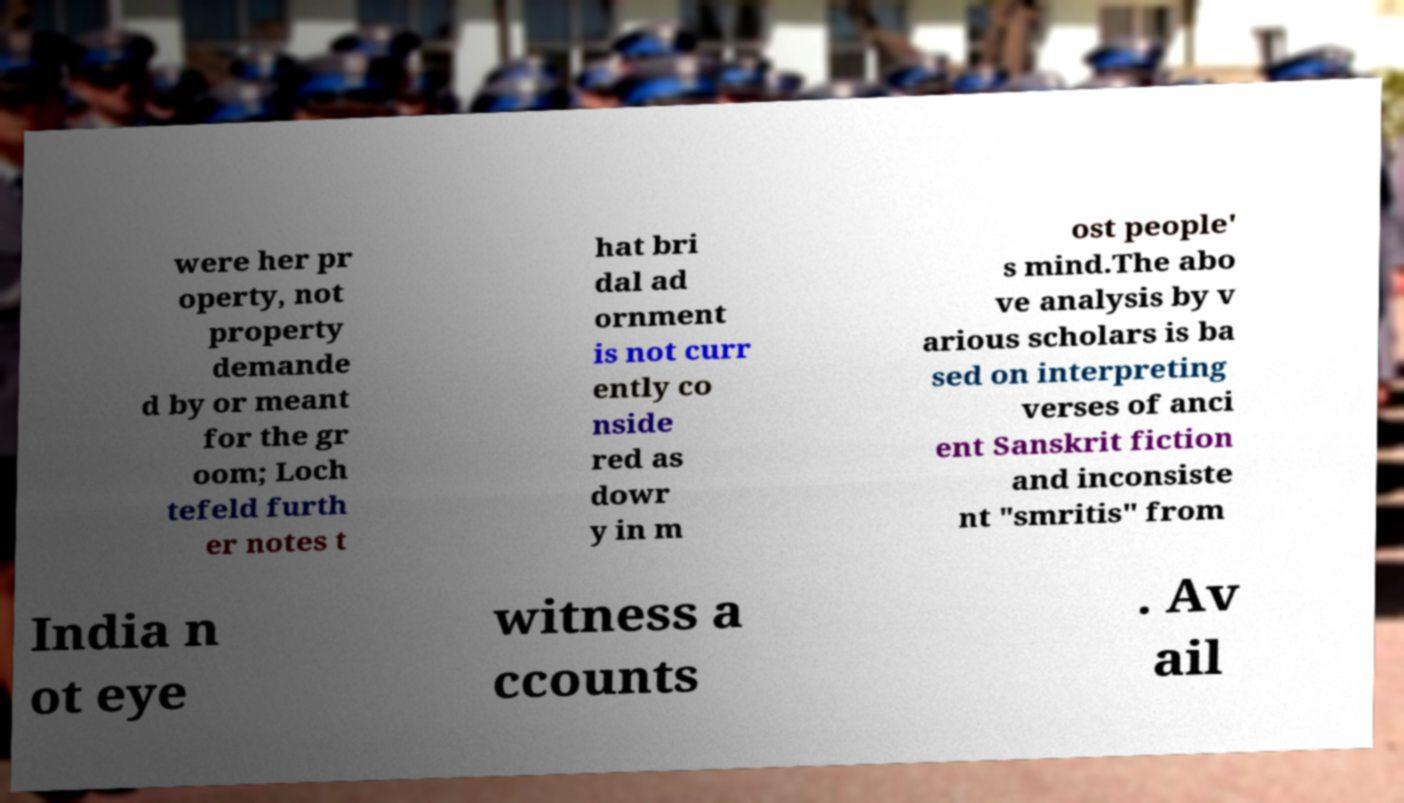Can you accurately transcribe the text from the provided image for me? were her pr operty, not property demande d by or meant for the gr oom; Loch tefeld furth er notes t hat bri dal ad ornment is not curr ently co nside red as dowr y in m ost people' s mind.The abo ve analysis by v arious scholars is ba sed on interpreting verses of anci ent Sanskrit fiction and inconsiste nt "smritis" from India n ot eye witness a ccounts . Av ail 